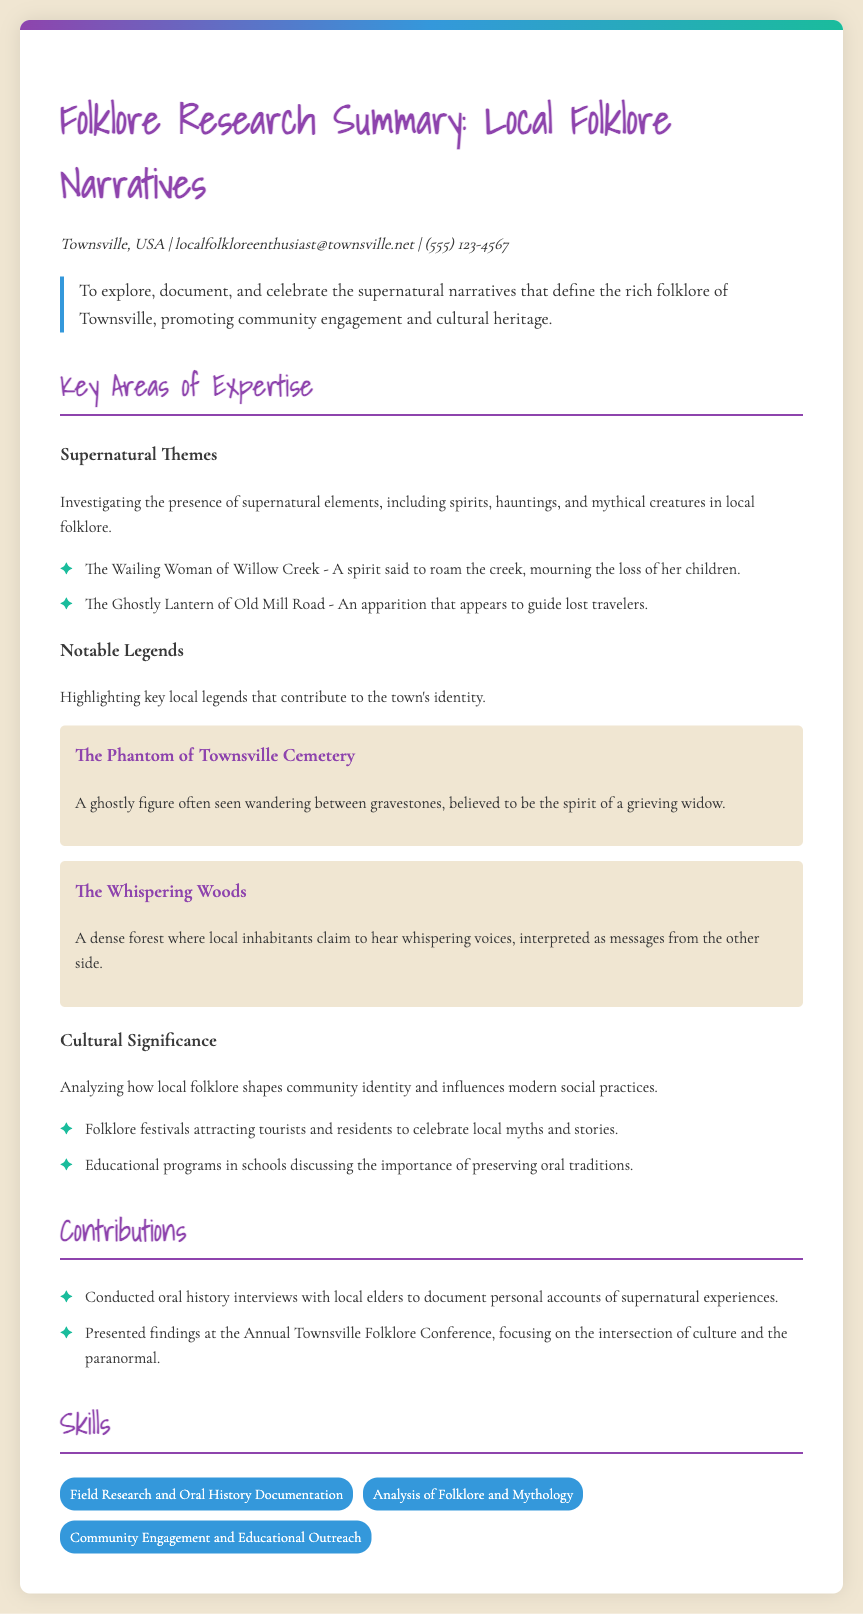What is the name of the applicant? The name is likely stated in the title or introduction of the document.
Answer: Folklore Research Summary: Local Folklore Narratives What is the main objective? The main objective outlines the intentions of the applicant in the CV.
Answer: Explore, document, and celebrate supernatural narratives How many notable legends are highlighted? The number can be counted from the section detailing notable legends.
Answer: Two What is the contact email of the applicant? The contact email is found in the contact information section of the document.
Answer: localfolkloreenthusiast@townsville.net Which spirit is said to roam Willow Creek? The question looks for a specific folklore entity mentioned in the supernatural themes.
Answer: The Wailing Woman What specific event was presented at the conference? This question seeks details about contributions made by the applicant.
Answer: Intersection of culture and the paranormal How many skills are listed in the skills section? The total number of skills can be counted in the corresponding section.
Answer: Three What type of research method is emphasized in the skills? The methods stated in the skills section are specifically named there.
Answer: Field Research and Oral History Documentation What community activity is mentioned related to folklore? This question seeks specific types of activities mentioned in the document.
Answer: Folklore festivals 